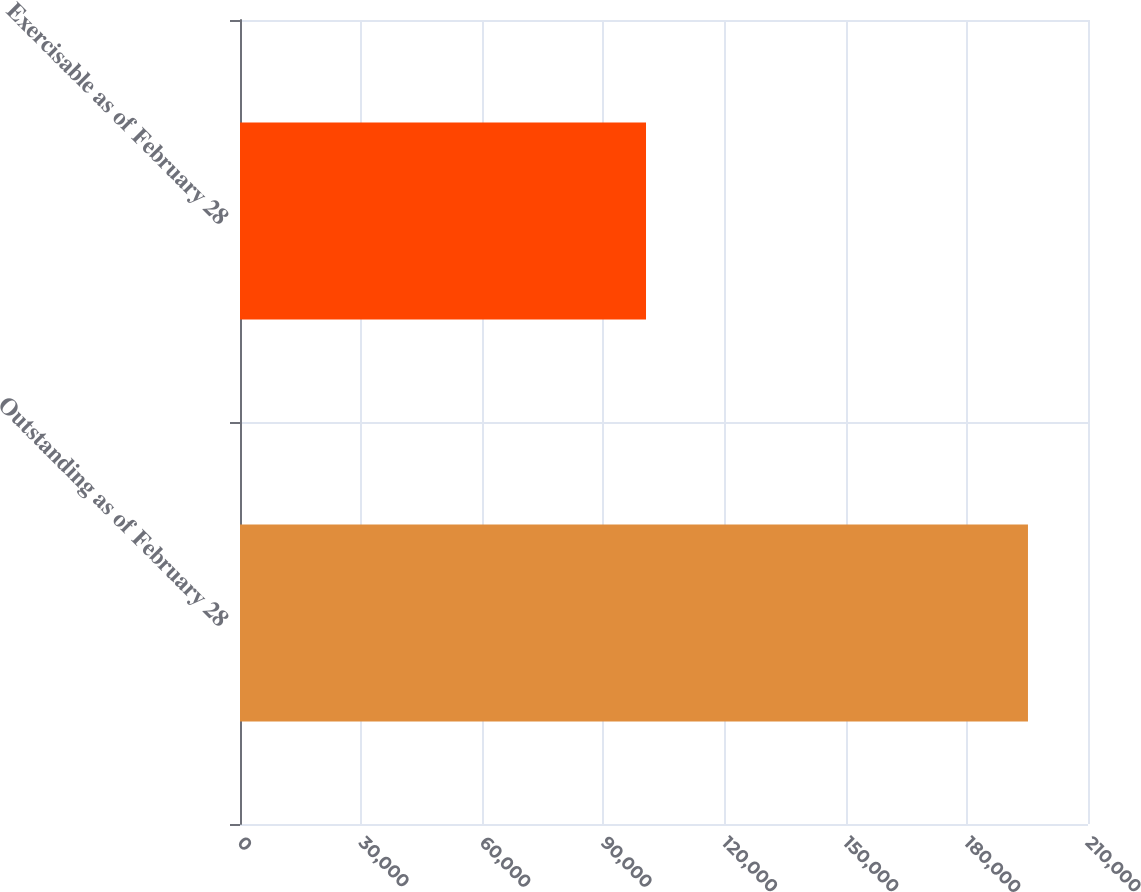Convert chart. <chart><loc_0><loc_0><loc_500><loc_500><bar_chart><fcel>Outstanding as of February 28<fcel>Exercisable as of February 28<nl><fcel>195134<fcel>100545<nl></chart> 